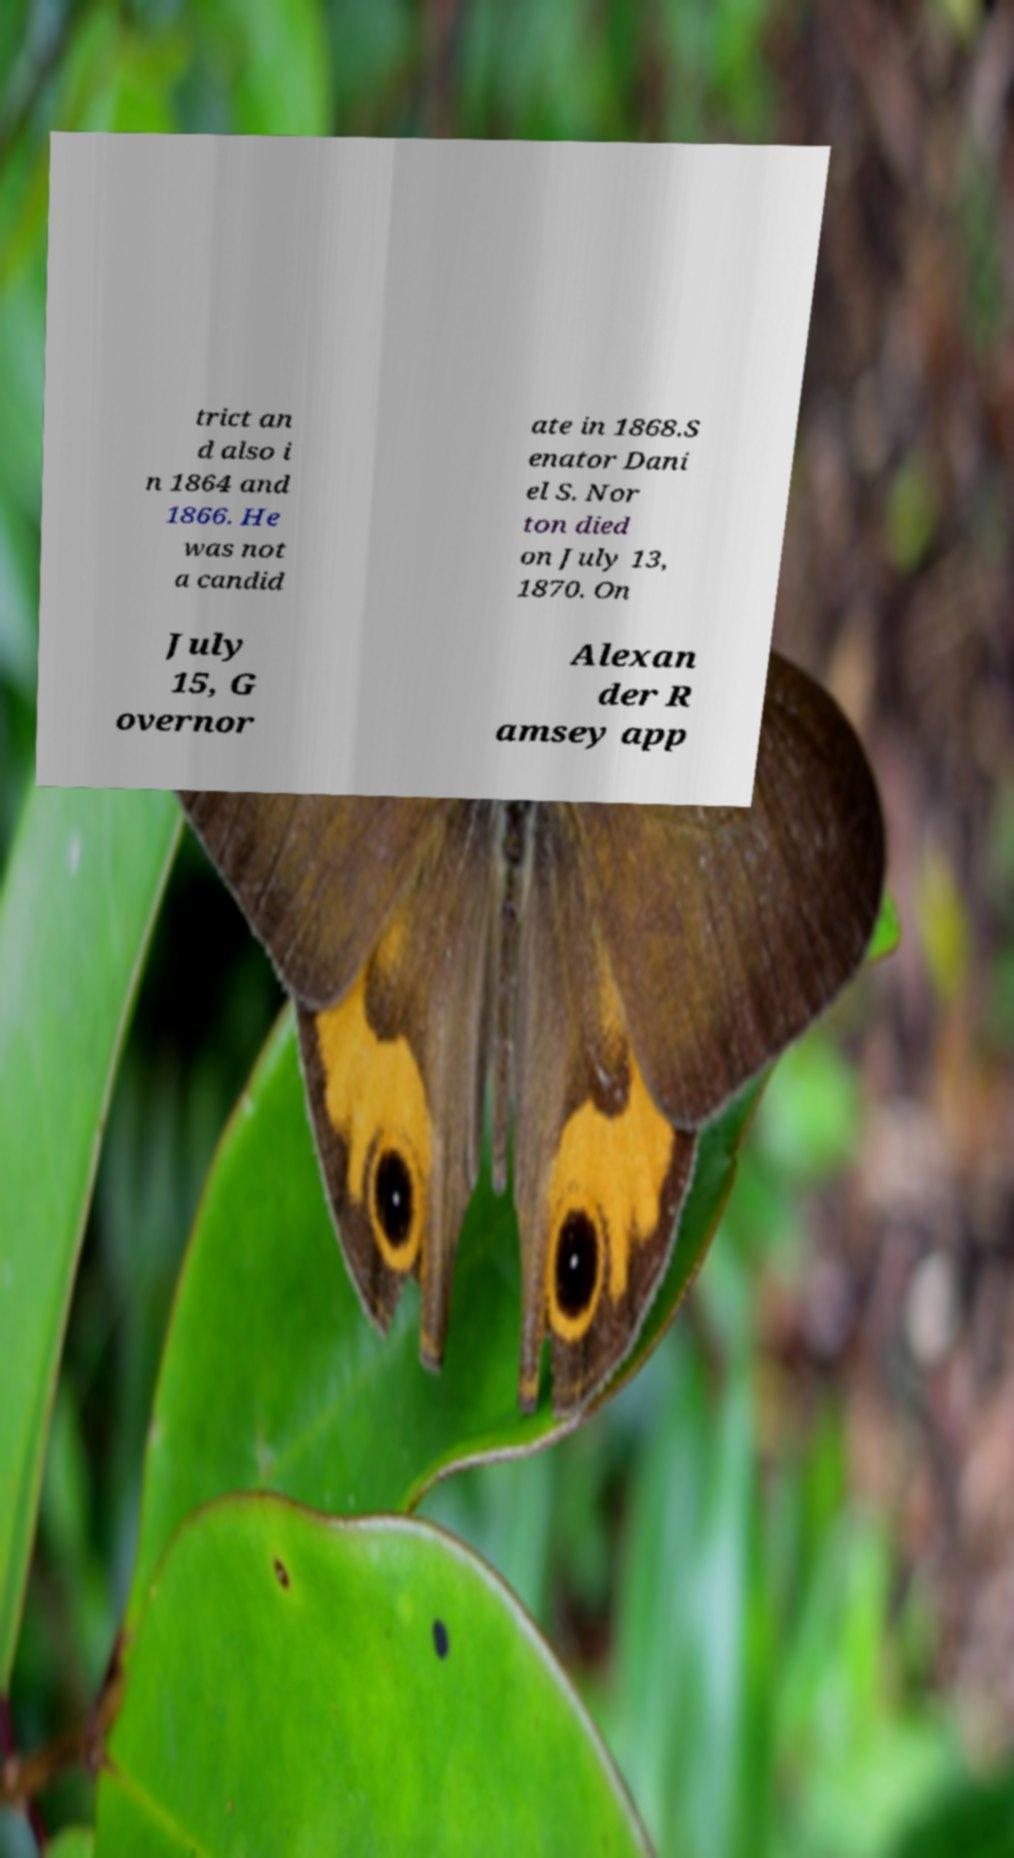Can you accurately transcribe the text from the provided image for me? trict an d also i n 1864 and 1866. He was not a candid ate in 1868.S enator Dani el S. Nor ton died on July 13, 1870. On July 15, G overnor Alexan der R amsey app 